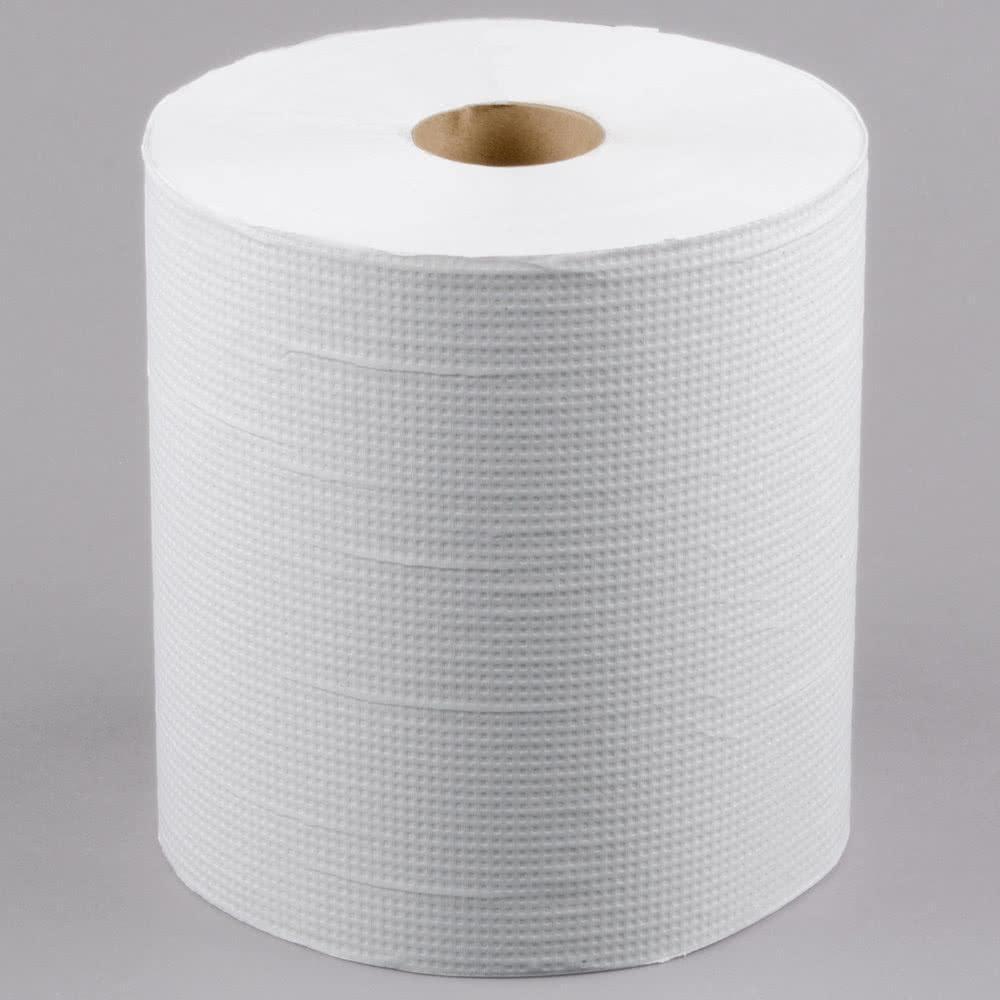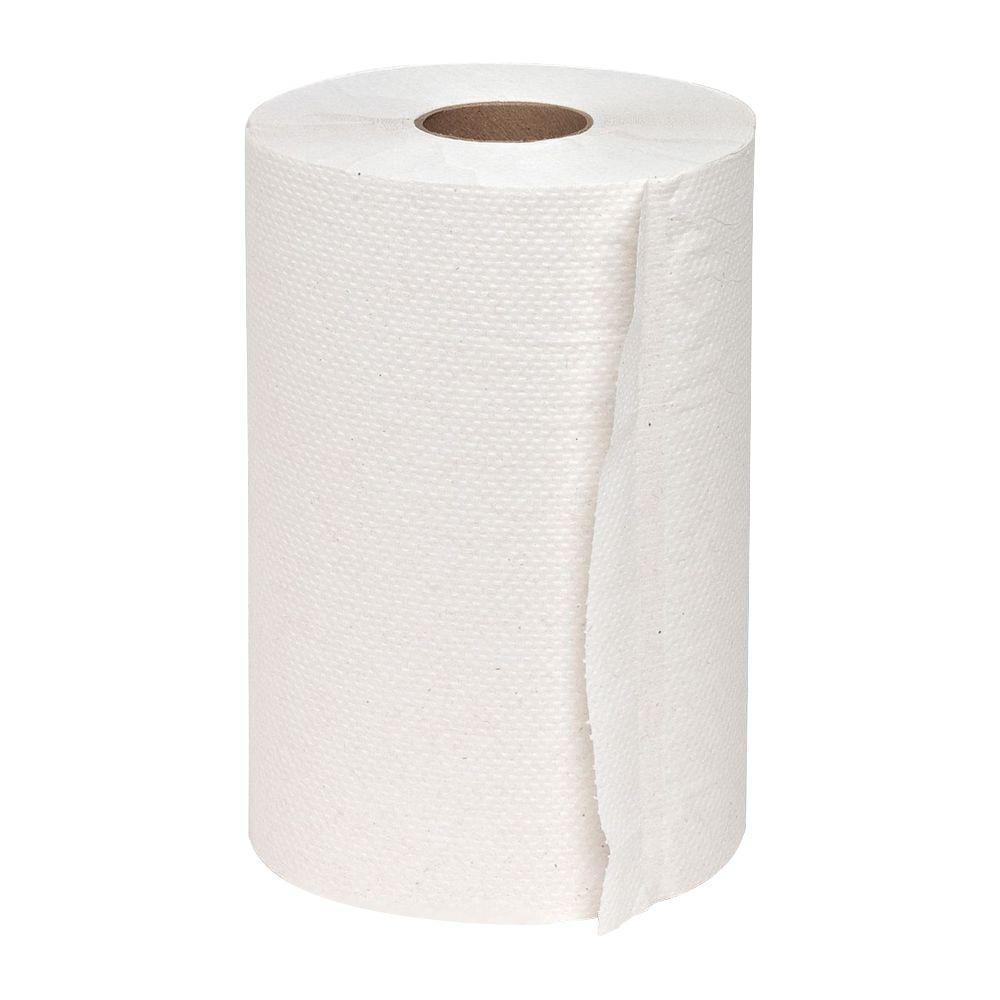The first image is the image on the left, the second image is the image on the right. Considering the images on both sides, is "In at least one image there is a single role of toilet paper with and open unruptured hole in the middle with the paper unrolling at least one sheet." valid? Answer yes or no. No. The first image is the image on the left, the second image is the image on the right. For the images shown, is this caption "Each image features a single white upright roll of paper towels with no sheet of towel extending out past the roll." true? Answer yes or no. Yes. 